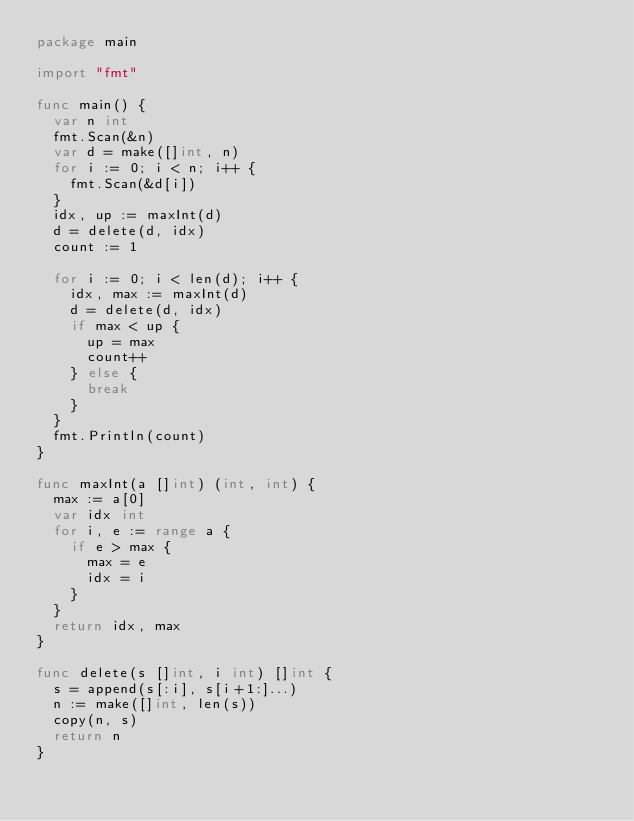<code> <loc_0><loc_0><loc_500><loc_500><_Go_>package main

import "fmt"

func main() {
	var n int
	fmt.Scan(&n)
	var d = make([]int, n)
	for i := 0; i < n; i++ {
		fmt.Scan(&d[i])
	}
	idx, up := maxInt(d)
	d = delete(d, idx)
	count := 1

	for i := 0; i < len(d); i++ {
		idx, max := maxInt(d)
		d = delete(d, idx)
		if max < up {
			up = max
			count++
		} else {
			break
		}
	}
	fmt.Println(count)
}

func maxInt(a []int) (int, int) {
	max := a[0]
	var idx int
	for i, e := range a {
		if e > max {
			max = e
			idx = i
		}
	}
	return idx, max
}

func delete(s []int, i int) []int {
	s = append(s[:i], s[i+1:]...)
	n := make([]int, len(s))
	copy(n, s)
	return n
}
</code> 